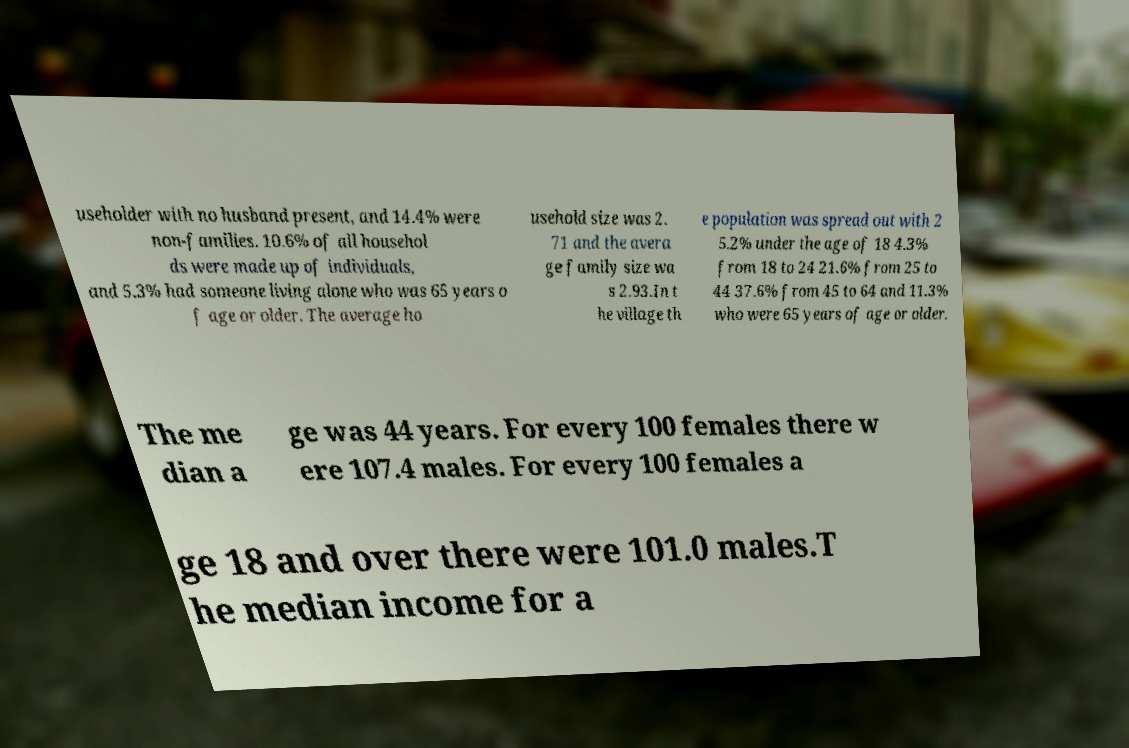Could you assist in decoding the text presented in this image and type it out clearly? useholder with no husband present, and 14.4% were non-families. 10.6% of all househol ds were made up of individuals, and 5.3% had someone living alone who was 65 years o f age or older. The average ho usehold size was 2. 71 and the avera ge family size wa s 2.93.In t he village th e population was spread out with 2 5.2% under the age of 18 4.3% from 18 to 24 21.6% from 25 to 44 37.6% from 45 to 64 and 11.3% who were 65 years of age or older. The me dian a ge was 44 years. For every 100 females there w ere 107.4 males. For every 100 females a ge 18 and over there were 101.0 males.T he median income for a 